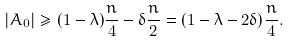<formula> <loc_0><loc_0><loc_500><loc_500>| A _ { 0 } | \geq ( 1 - \lambda ) \frac { n } { 4 } - \delta \frac { n } { 2 } = ( 1 - \lambda - 2 \delta ) \frac { n } { 4 } .</formula> 